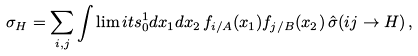<formula> <loc_0><loc_0><loc_500><loc_500>\sigma _ { H } = \sum _ { i , j } \int \lim i t s _ { 0 } ^ { 1 } d x _ { 1 } d x _ { 2 } \, f _ { i / A } ( x _ { 1 } ) f _ { j / B } ( x _ { 2 } ) \, \hat { \sigma } ( i j \rightarrow H ) \, ,</formula> 